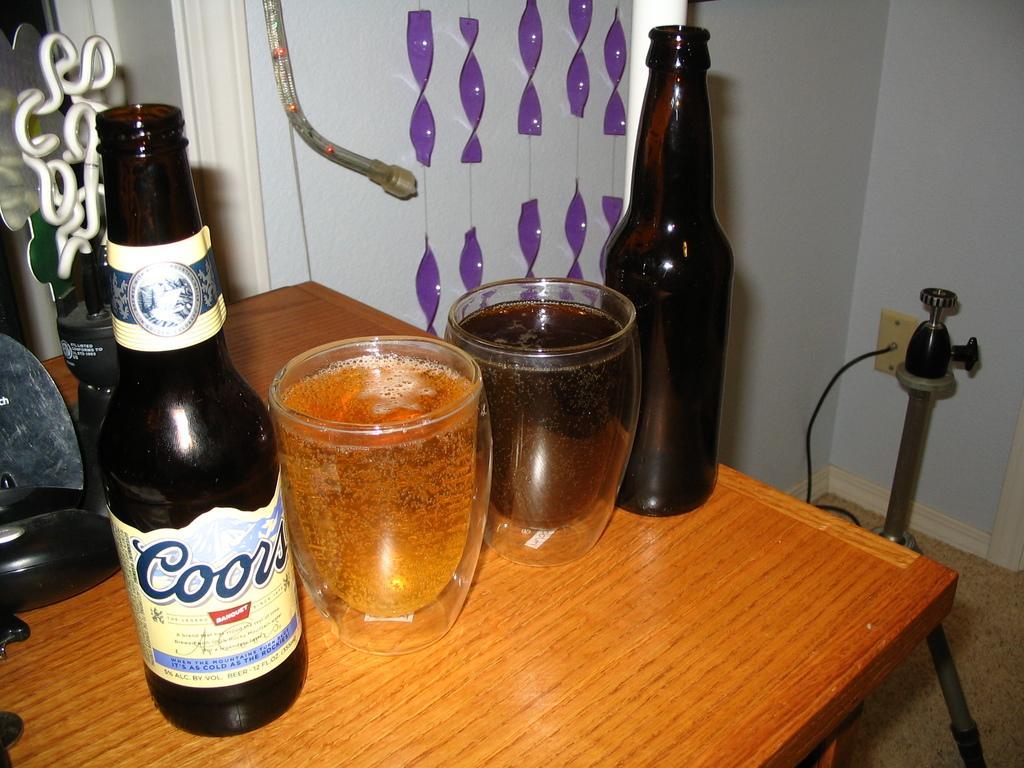Please provide a concise description of this image. In this image, we can see a table contains bottles and glasses. There are decors at the top of the image. There is a pipe in the bottom right of the image. There is an object in front of the wall. 